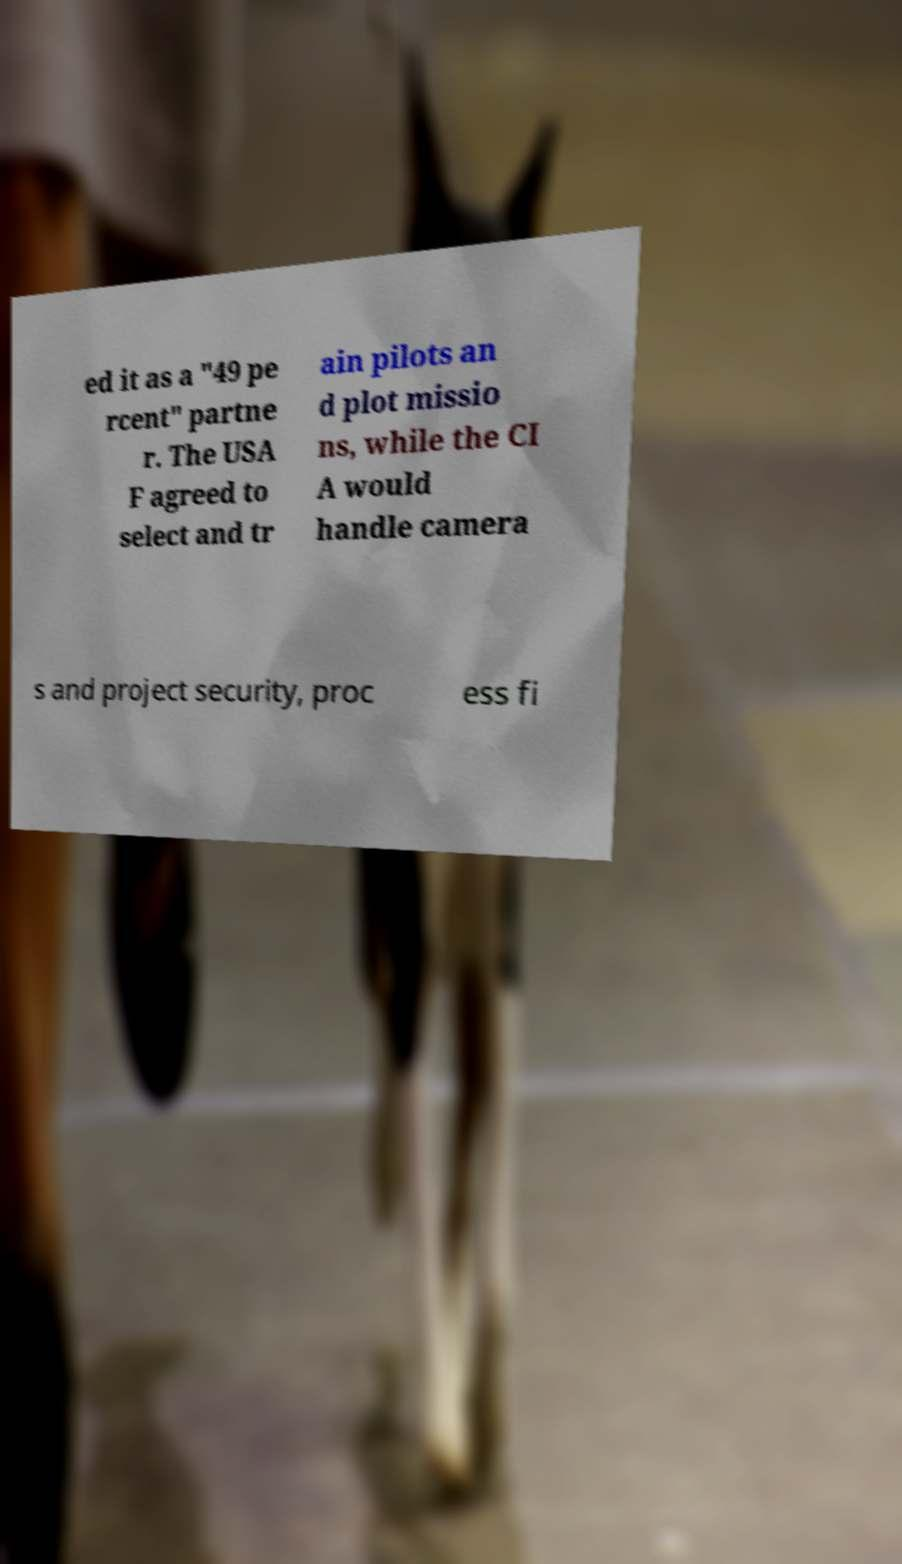Please read and relay the text visible in this image. What does it say? ed it as a "49 pe rcent" partne r. The USA F agreed to select and tr ain pilots an d plot missio ns, while the CI A would handle camera s and project security, proc ess fi 